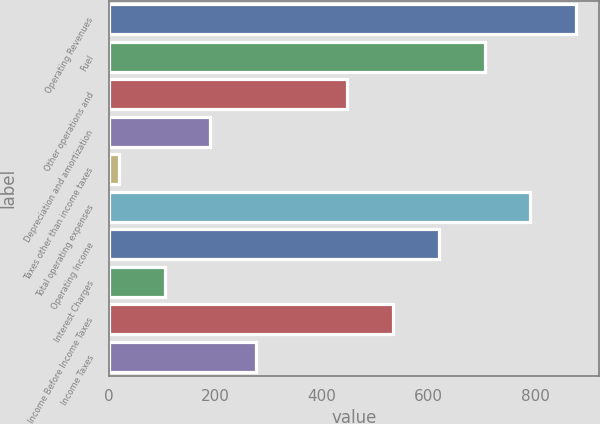<chart> <loc_0><loc_0><loc_500><loc_500><bar_chart><fcel>Operating Revenues<fcel>Fuel<fcel>Other operations and<fcel>Depreciation and amortization<fcel>Taxes other than income taxes<fcel>Total operating expenses<fcel>Operating Income<fcel>Interest Charges<fcel>Income Before Income Taxes<fcel>Income Taxes<nl><fcel>876<fcel>704.6<fcel>447.5<fcel>190.4<fcel>19<fcel>790.3<fcel>618.9<fcel>104.7<fcel>533.2<fcel>276.1<nl></chart> 